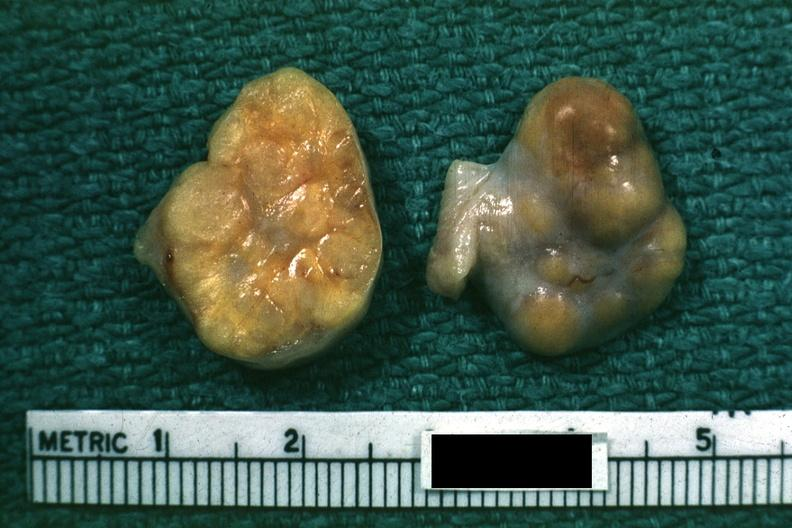how is this good yellow color slide labeled cell tumor?
Answer the question using a single word or phrase. Granulosa 